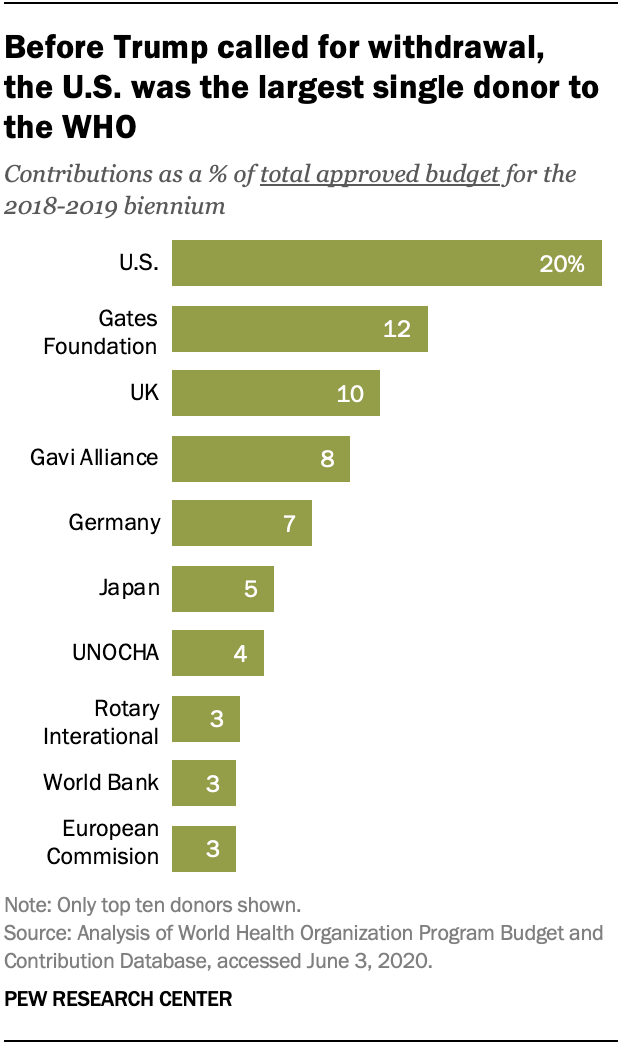Specify some key components in this picture. The median value of all the bars is 6. The country with the highest percentage value is the United States. 